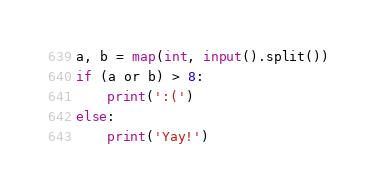<code> <loc_0><loc_0><loc_500><loc_500><_Python_>a, b = map(int, input().split())
if (a or b) > 8:
    print(':(')
else:
    print('Yay!')</code> 